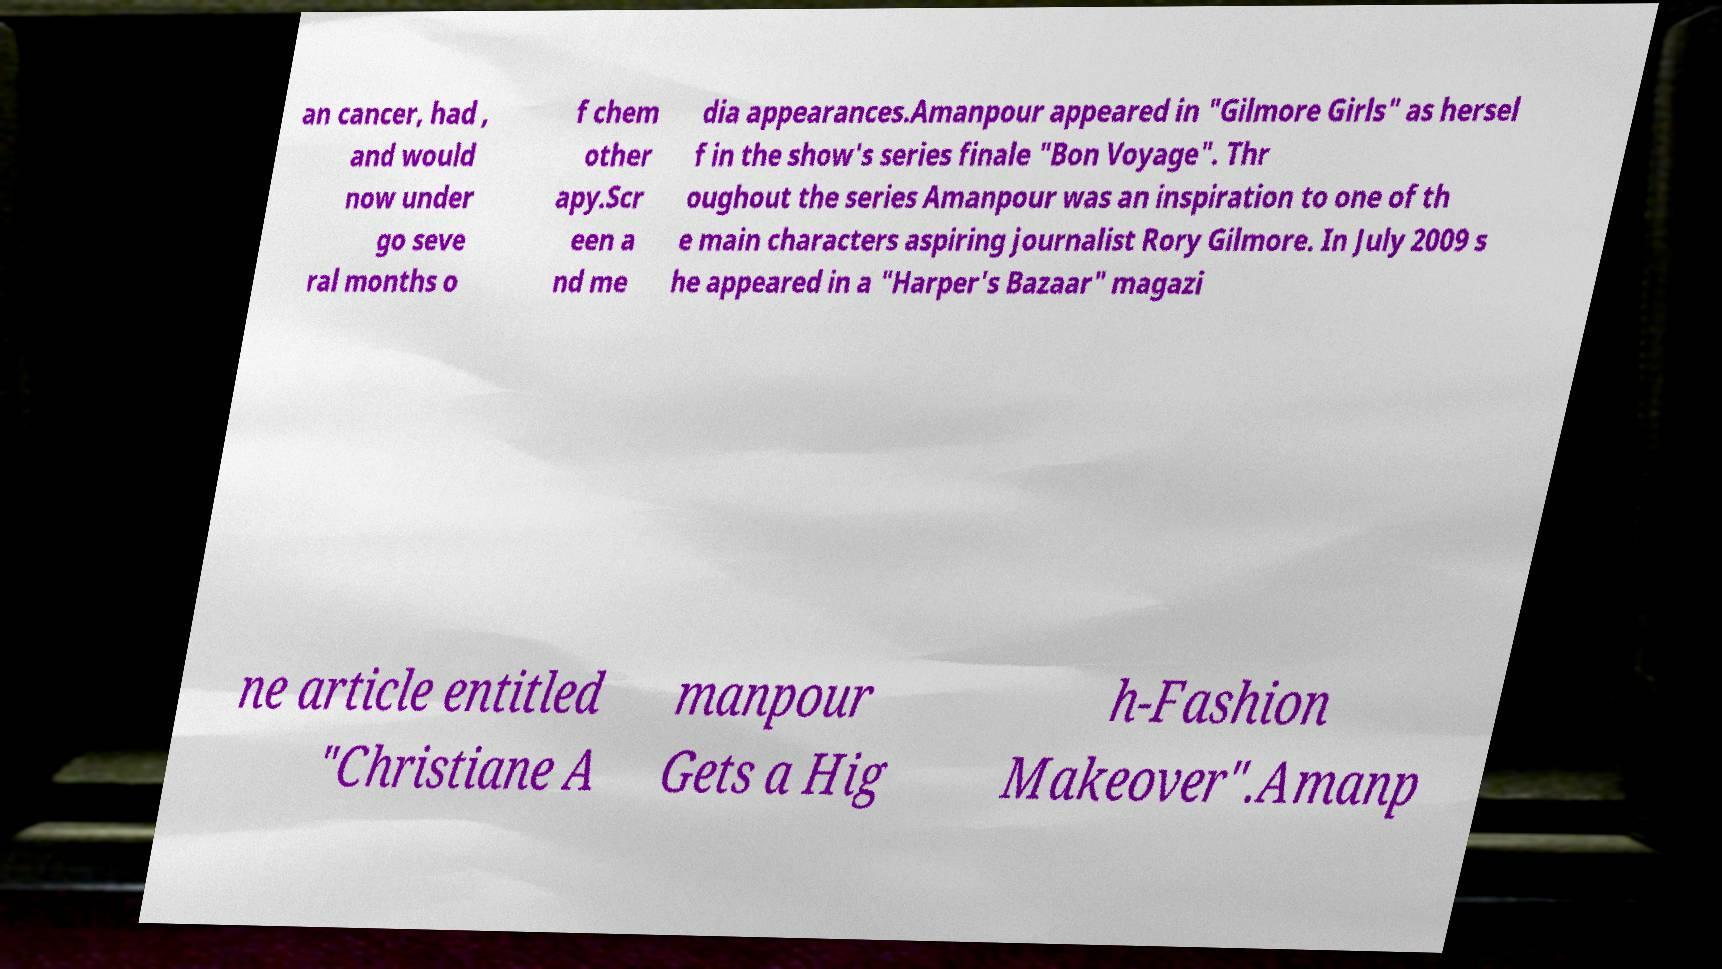I need the written content from this picture converted into text. Can you do that? an cancer, had , and would now under go seve ral months o f chem other apy.Scr een a nd me dia appearances.Amanpour appeared in "Gilmore Girls" as hersel f in the show's series finale "Bon Voyage". Thr oughout the series Amanpour was an inspiration to one of th e main characters aspiring journalist Rory Gilmore. In July 2009 s he appeared in a "Harper's Bazaar" magazi ne article entitled "Christiane A manpour Gets a Hig h-Fashion Makeover".Amanp 